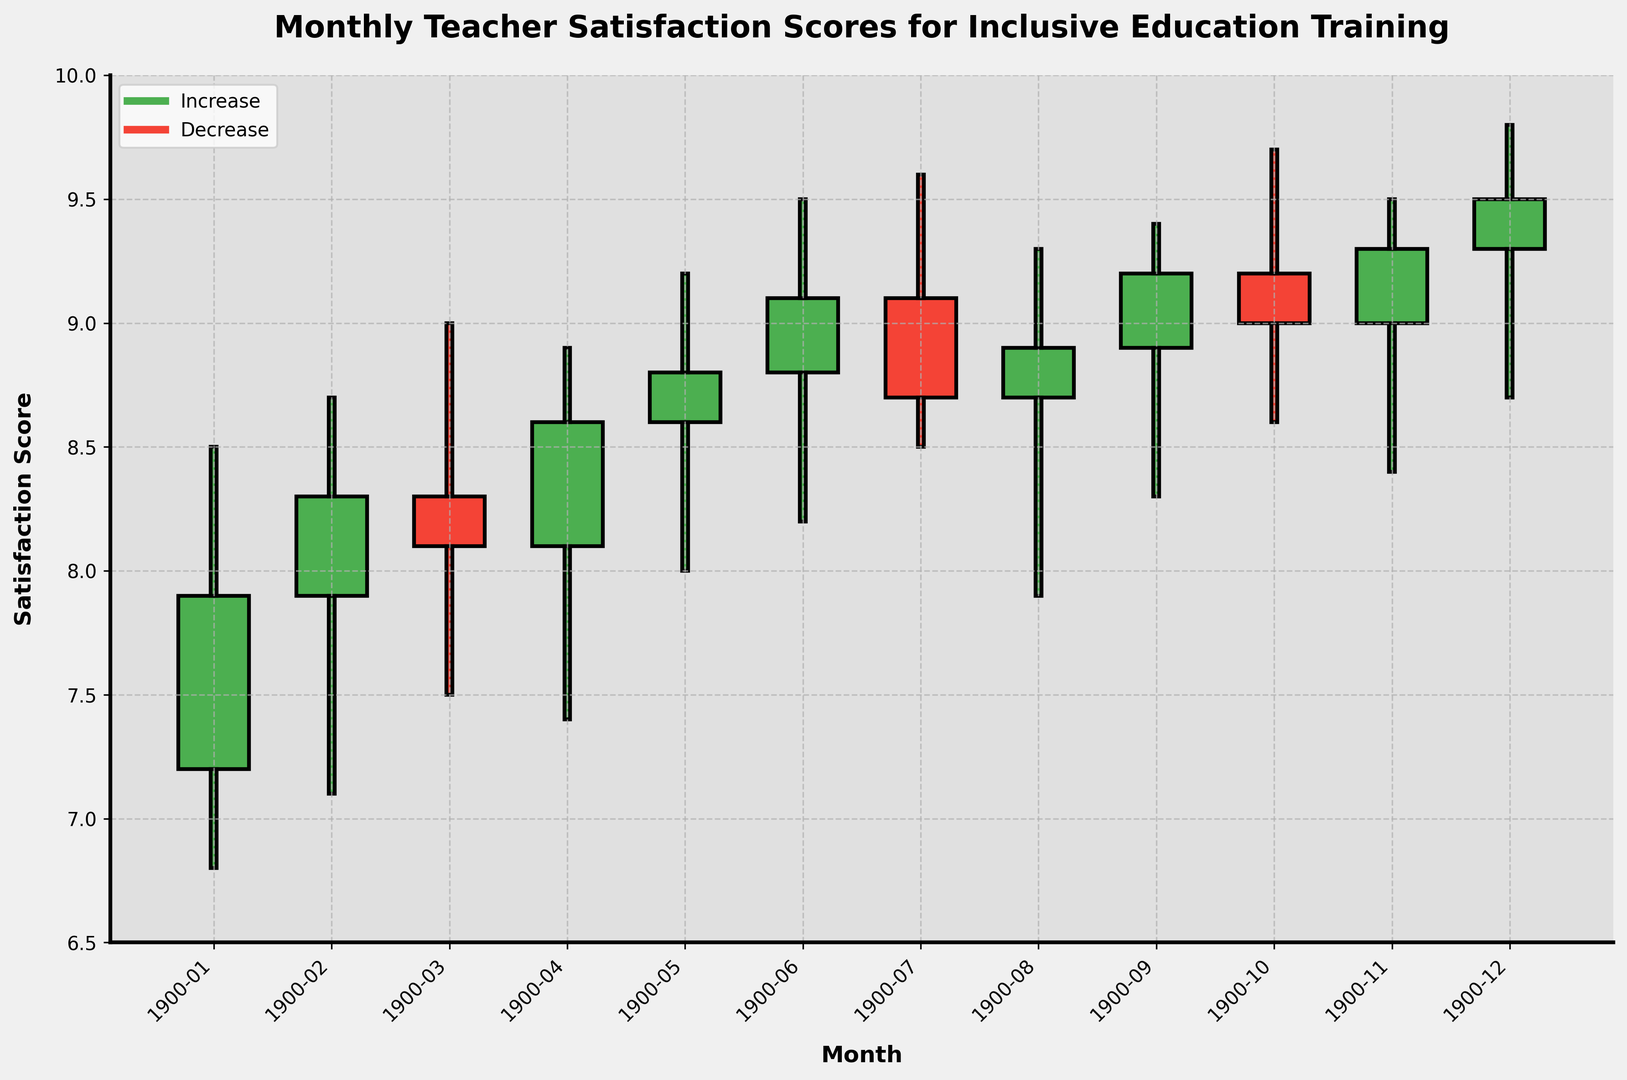Which month had the highest satisfaction score at the close? Look at the 'Close' column in the data or the highest point on the green bars of the candlestick chart. The highest close value is in December with a score of 9.5.
Answer: December Which month showed the biggest increase from open to close? Identify the months where the green bars are the tallest, indicating the greatest difference between the close and open values. For May, the increase is 8.8 - 8.6 = 0.2, while in June the increase is 9.1 - 8.8 = 0.3, making June the month with the biggest increase.
Answer: June Which month had the biggest drop from open to close? Identify the months where the red bars are the tallest, indicating the greatest difference between the open and close values. The biggest drop is in July, from 9.1 to 8.7, with a difference of 0.4.
Answer: July What is the average closing satisfaction score for the year? Sum up all the closing scores and divide by the number of months: (7.9 + 8.3 + 8.1 + 8.6 + 8.8 + 9.1 + 8.7 + 8.9 + 9.2 + 9.0 + 9.3 + 9.5) / 12 = 8.65.
Answer: 8.65 Which two consecutive months showed an upward trend in satisfaction scores? Look for months where the 'Close' value of one month is lower than the 'Close' value of the next month. February (8.3) and March (8.1) do not show an upward trend, but May (8.8) and June (9.1) do.
Answer: May and June In which month did the satisfaction score reach its lowest point? Identify the smallest value in the 'Low' column or the lowest point on any candlestick. The lowest score is 6.8 in January.
Answer: January How many months showed a downward trend (closing score lower than the opening score)? Count the number of red bars indicating months where the closing score is lower than the opening score. These months are March, July, and October, so there are 3 months with a downward trend.
Answer: 3 What is the range of satisfaction scores in June? The range is the difference between the 'High' and 'Low' values for June. The high is 9.5 and the low is 8.2, giving a range of 9.5 - 8.2 = 1.3.
Answer: 1.3 Compared to February, how much higher was the highest satisfaction score in December? The highest satisfaction score in February was 8.7 and in December was 9.8. The difference is 9.8 - 8.7 = 1.1.
Answer: 1.1 